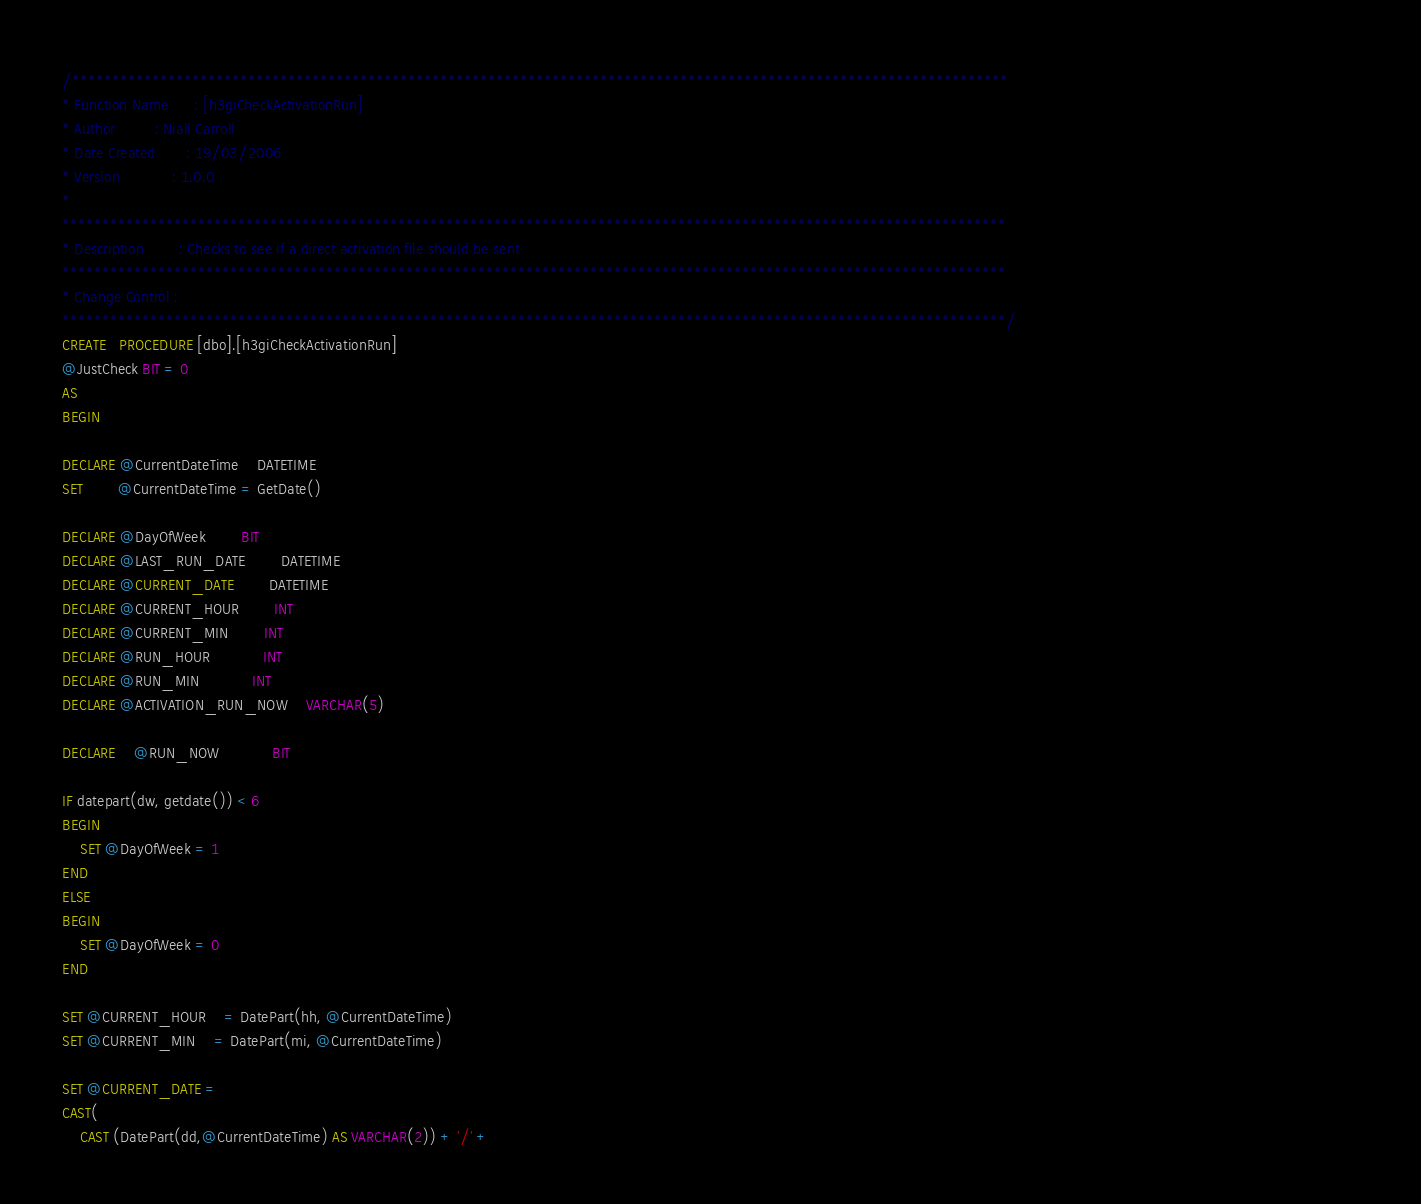Convert code to text. <code><loc_0><loc_0><loc_500><loc_500><_SQL_>/*********************************************************************************************************************																				
* Function Name		: [h3giCheckActivationRun]
* Author			: Niall Carroll
* Date Created		: 19/03/2006
* Version			: 1.0.0
*					
**********************************************************************************************************************
* Description		: Checks to see if a direct activation file should be sent
**********************************************************************************************************************
* Change Control	: 
**********************************************************************************************************************/
CREATE   PROCEDURE [dbo].[h3giCheckActivationRun]  
@JustCheck BIT = 0
AS  
BEGIN

DECLARE @CurrentDateTime	DATETIME
SET		@CurrentDateTime = GetDate()

DECLARE @DayOfWeek		BIT
DECLARE @LAST_RUN_DATE 		DATETIME
DECLARE @CURRENT_DATE		DATETIME
DECLARE @CURRENT_HOUR		INT
DECLARE @CURRENT_MIN		INT
DECLARE @RUN_HOUR			INT
DECLARE @RUN_MIN			INT
DECLARE @ACTIVATION_RUN_NOW	VARCHAR(5)

DECLARE	@RUN_NOW			BIT

IF datepart(dw, getdate()) < 6
BEGIN
	SET @DayOfWeek = 1
END
ELSE
BEGIN
	SET @DayOfWeek = 0
END

SET @CURRENT_HOUR 	= DatePart(hh, @CurrentDateTime)
SET @CURRENT_MIN 	= DatePart(mi, @CurrentDateTime)

SET @CURRENT_DATE =
CAST(
	CAST (DatePart(dd,@CurrentDateTime) AS VARCHAR(2)) + '/' +</code> 